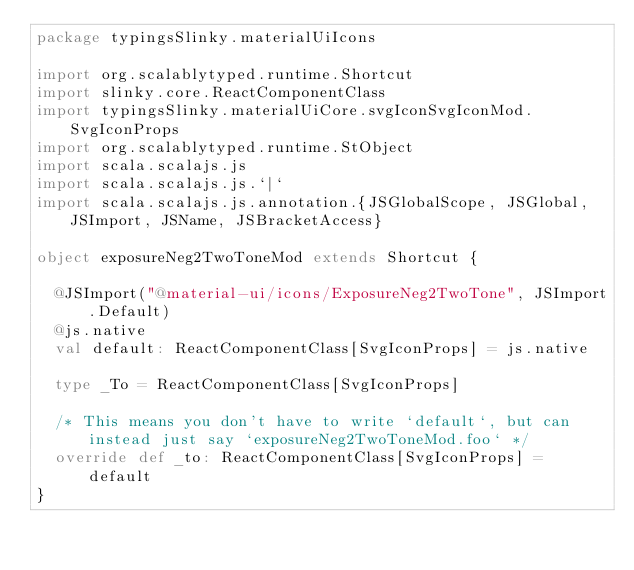<code> <loc_0><loc_0><loc_500><loc_500><_Scala_>package typingsSlinky.materialUiIcons

import org.scalablytyped.runtime.Shortcut
import slinky.core.ReactComponentClass
import typingsSlinky.materialUiCore.svgIconSvgIconMod.SvgIconProps
import org.scalablytyped.runtime.StObject
import scala.scalajs.js
import scala.scalajs.js.`|`
import scala.scalajs.js.annotation.{JSGlobalScope, JSGlobal, JSImport, JSName, JSBracketAccess}

object exposureNeg2TwoToneMod extends Shortcut {
  
  @JSImport("@material-ui/icons/ExposureNeg2TwoTone", JSImport.Default)
  @js.native
  val default: ReactComponentClass[SvgIconProps] = js.native
  
  type _To = ReactComponentClass[SvgIconProps]
  
  /* This means you don't have to write `default`, but can instead just say `exposureNeg2TwoToneMod.foo` */
  override def _to: ReactComponentClass[SvgIconProps] = default
}
</code> 